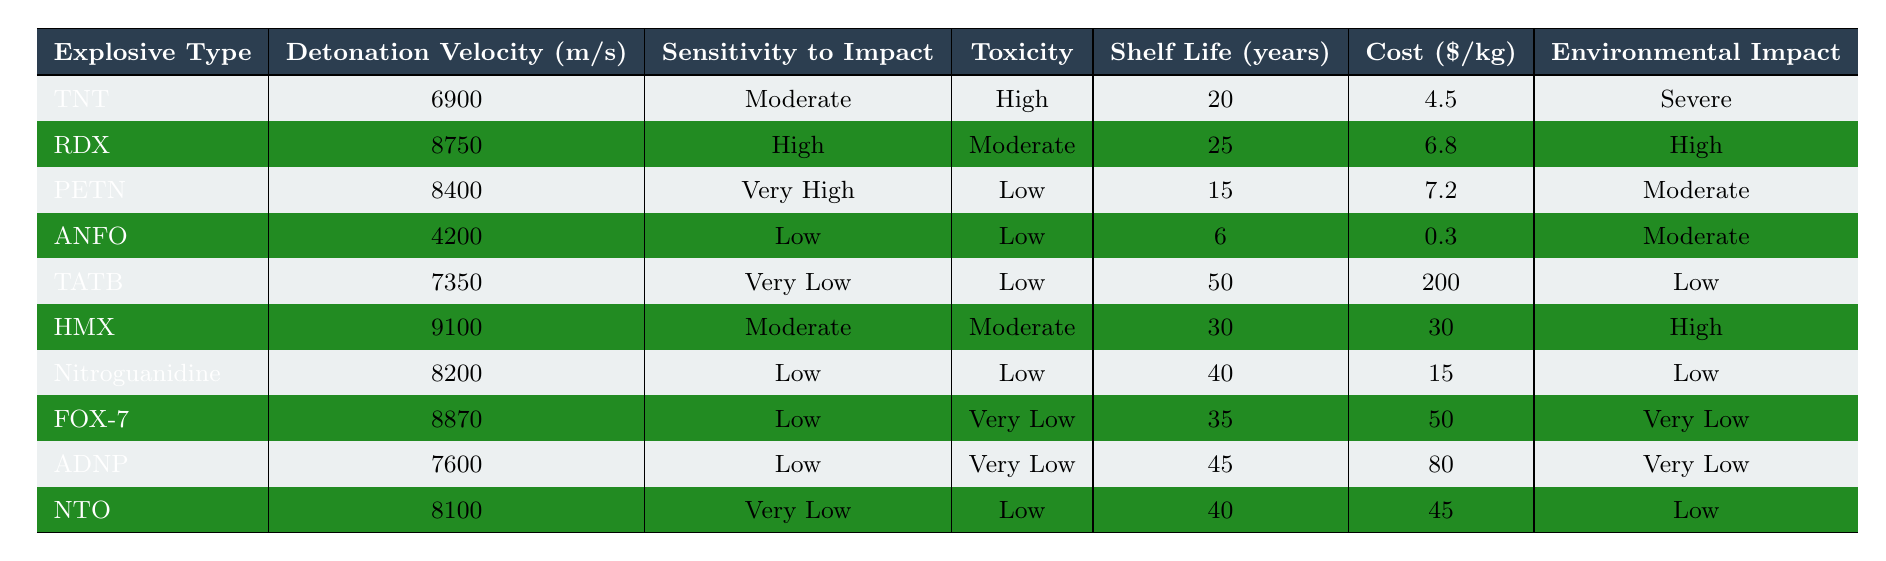What is the detonation velocity of TNT? The table lists the explosion properties of various explosives, and for TNT, the detonation velocity is specified as 6900 m/s.
Answer: 6900 m/s Which explosive has the highest toxicity? By examining the toxicity column, TNT is marked as 'High', which is the highest rating compared to the others listed (Moderate, Low, Very Low).
Answer: TNT What is the shelf life of PETN? The table explicitly provides information that the shelf life of PETN is 15 years.
Answer: 15 years Which explosive type is the least sensitive to impact? Looking at the sensitivity to impact column, TATB is categorized as 'Very Low', indicating it is the least sensitive compared to others like 'Low', 'Moderate', and 'High'.
Answer: TATB What is the cost difference between ANFO and TATB? ANFO costs $0.3/kg, while TATB costs $200/kg. The difference is $200 - $0.3 = $199.7.
Answer: $199.7 Which explosives have a shelf life of over 40 years? Filtering the shelf life column, TATB (50 years), Nitroguanidine (40 years), FOX-7 (35 years), and ADNP (45 years) fit this criterion. Thus, TATB and Nitroguanidine are the only ones that exceed 40 years.
Answer: TATB and Nitroguanidine Is the environmental impact of RDX lower than that of HMX? The table shows RDX has a 'High' environmental impact and HMX also has a 'High' environmental impact, indicating they are equal. Thus, the environmental impact of RDX is not lower.
Answer: No What is the average cost of the explosives listed? The cost values ($4.5, $6.8, $7.2, $0.3, $200, $30, $15, $50, $80, $45) sum to $403.8. With 10 explosives, the average cost is $403.8 / 10 = $40.38.
Answer: $40.38 Which explosive type has both low toxicity and low environmental impact? By analyzing the table, Nitroguanidine fits as it has 'Low' toxicity and 'Low' environmental impact.
Answer: Nitroguanidine What is the detonation velocity range of the explosives? Finding the maximum and minimum values from the detonation velocity column, TNT has 6900 m/s, and HMX has 9100 m/s. Hence the range is 9100 - 4200 = 4900 m/s.
Answer: 4900 m/s 